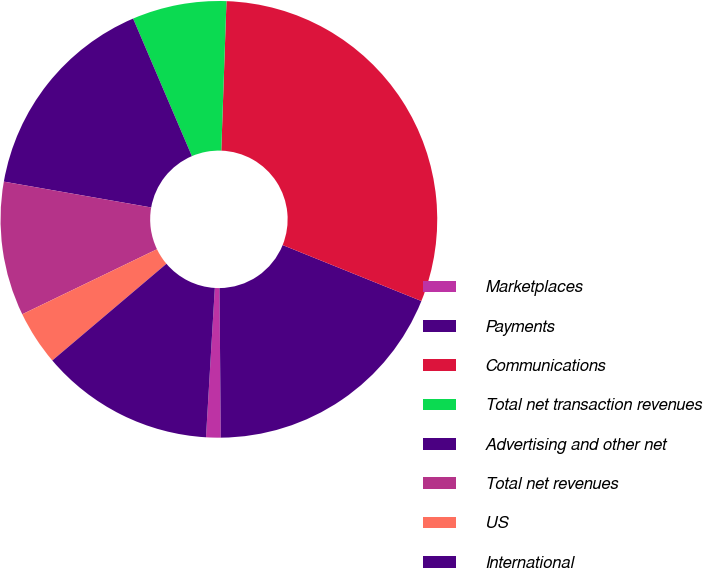Convert chart to OTSL. <chart><loc_0><loc_0><loc_500><loc_500><pie_chart><fcel>Marketplaces<fcel>Payments<fcel>Communications<fcel>Total net transaction revenues<fcel>Advertising and other net<fcel>Total net revenues<fcel>US<fcel>International<nl><fcel>1.08%<fcel>18.76%<fcel>30.55%<fcel>6.98%<fcel>15.81%<fcel>9.92%<fcel>4.03%<fcel>12.87%<nl></chart> 